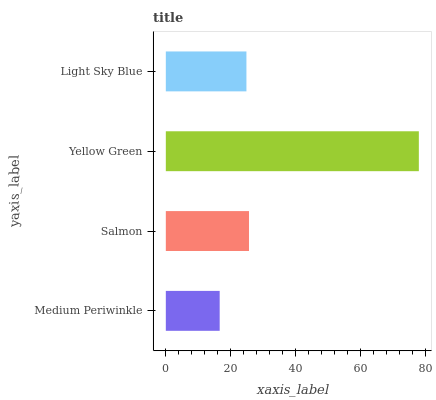Is Medium Periwinkle the minimum?
Answer yes or no. Yes. Is Yellow Green the maximum?
Answer yes or no. Yes. Is Salmon the minimum?
Answer yes or no. No. Is Salmon the maximum?
Answer yes or no. No. Is Salmon greater than Medium Periwinkle?
Answer yes or no. Yes. Is Medium Periwinkle less than Salmon?
Answer yes or no. Yes. Is Medium Periwinkle greater than Salmon?
Answer yes or no. No. Is Salmon less than Medium Periwinkle?
Answer yes or no. No. Is Salmon the high median?
Answer yes or no. Yes. Is Light Sky Blue the low median?
Answer yes or no. Yes. Is Medium Periwinkle the high median?
Answer yes or no. No. Is Yellow Green the low median?
Answer yes or no. No. 